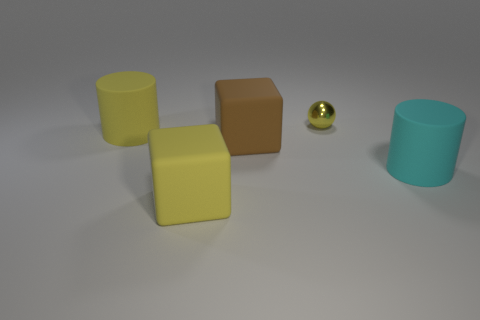Add 1 small yellow balls. How many objects exist? 6 Subtract all cubes. How many objects are left? 3 Add 5 yellow balls. How many yellow balls are left? 6 Add 5 tiny yellow metal objects. How many tiny yellow metal objects exist? 6 Subtract 0 red spheres. How many objects are left? 5 Subtract all yellow things. Subtract all big matte balls. How many objects are left? 2 